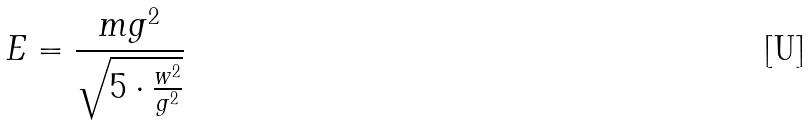<formula> <loc_0><loc_0><loc_500><loc_500>E = \frac { m g ^ { 2 } } { \sqrt { 5 \cdot \frac { w ^ { 2 } } { g ^ { 2 } } } }</formula> 